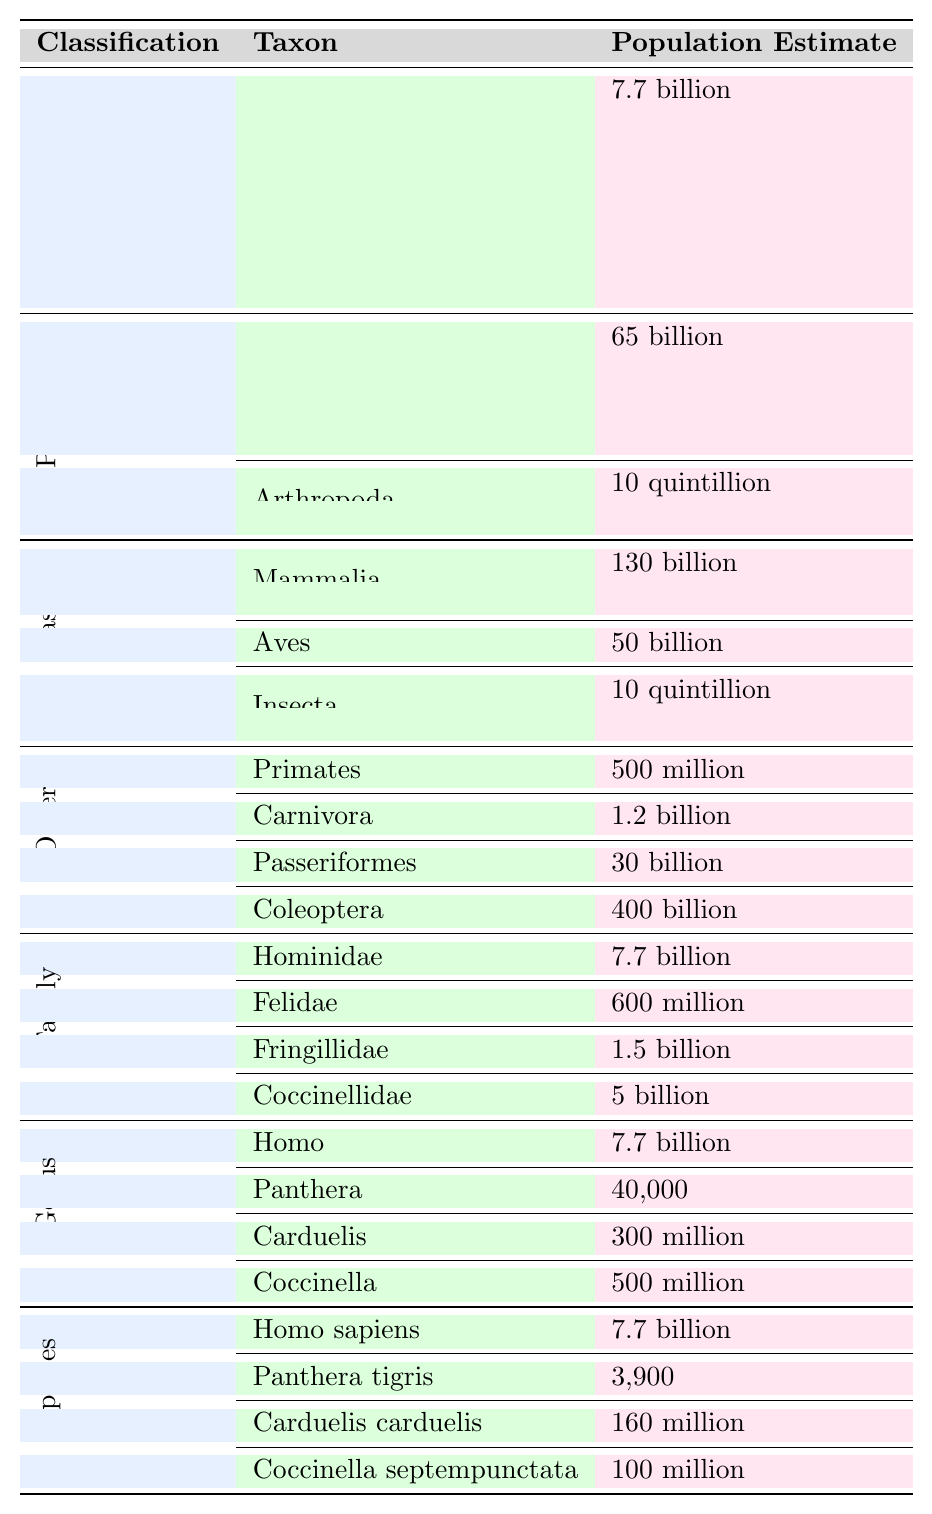What is the population estimate for the kingdom Animalia? The table states that the population estimate for the kingdom Animalia is 7.7 billion.
Answer: 7.7 billion What is the population estimate for the phylum Chordata? According to the table, the population estimate for Chordata is listed as 65 billion.
Answer: 65 billion Which class has the highest population estimate? The class Mammalia has the highest population estimate at 130 billion, as shown in the table.
Answer: Mammalia What is the population estimate for the order Carnivora? The order Carnivora has a population estimate of 1.2 billion according to the table.
Answer: 1.2 billion How many species are listed under the genus Carduelis? The genus Carduelis has one species listed, which is Carduelis carduelis, with a population estimate of 160 million.
Answer: 1 species What is the total population estimated for the class Aves and Mammalia combined? The population estimate for Aves is 50 billion and for Mammalia is 130 billion. Adding them gives 50 billion + 130 billion = 180 billion.
Answer: 180 billion Is the population of Panthera tigris greater than 5,000? The population of Panthera tigris is 3,900 as per the table, which is less than 5,000. Thus, the statement is false.
Answer: No What is the population estimate difference between the family Coccinellidae and the family Felidae? Coccinellidae has a population estimate of 5 billion, while Felidae has 600 million. The difference is 5 billion - 600 million = 4.4 billion.
Answer: 4.4 billion How does the total population of the genus Coccinella compare to that of Panthera? The genus Coccinella has a population estimate of 500 million and Panthera has 40,000. The first is significantly higher than the second.
Answer: Coccinella is higher What is the total population estimate for all species listed under the class Insecta? The only family listed under the class Insecta is Coccinellidae with 5 billion. Thus, the total population estimate is solely that value.
Answer: 5 billion 